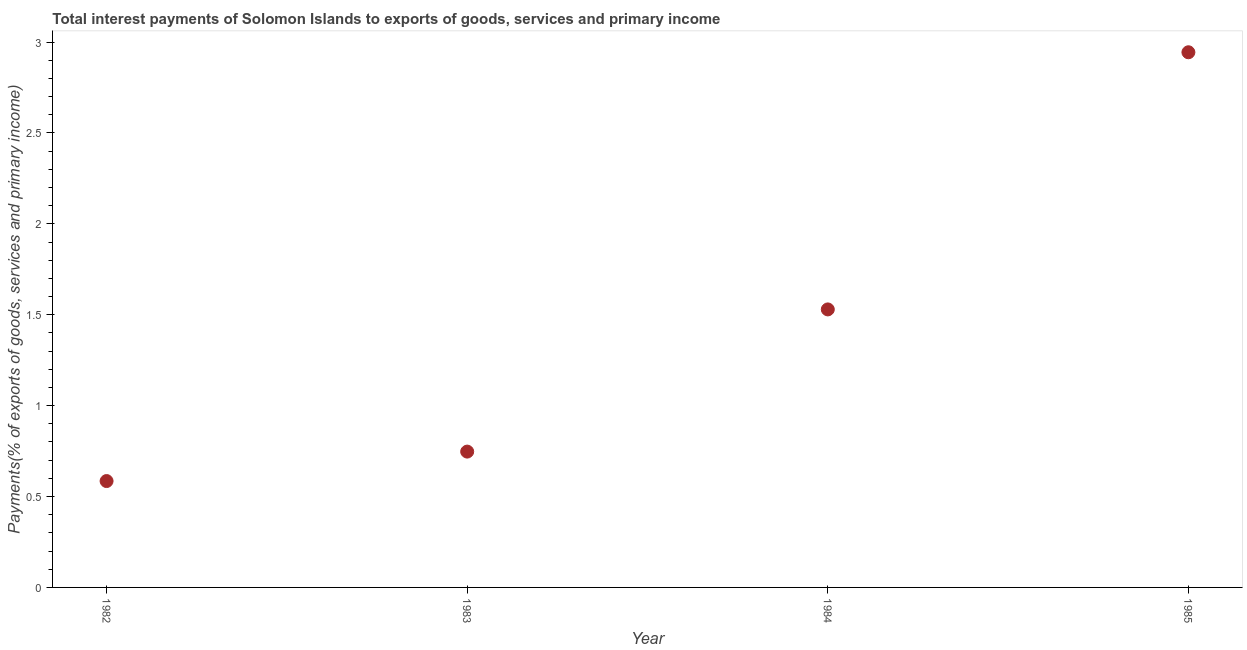What is the total interest payments on external debt in 1984?
Your response must be concise. 1.53. Across all years, what is the maximum total interest payments on external debt?
Offer a terse response. 2.94. Across all years, what is the minimum total interest payments on external debt?
Your answer should be compact. 0.59. In which year was the total interest payments on external debt minimum?
Provide a succinct answer. 1982. What is the sum of the total interest payments on external debt?
Provide a succinct answer. 5.81. What is the difference between the total interest payments on external debt in 1982 and 1984?
Keep it short and to the point. -0.94. What is the average total interest payments on external debt per year?
Provide a succinct answer. 1.45. What is the median total interest payments on external debt?
Provide a succinct answer. 1.14. What is the ratio of the total interest payments on external debt in 1982 to that in 1983?
Offer a terse response. 0.78. Is the total interest payments on external debt in 1982 less than that in 1983?
Offer a very short reply. Yes. What is the difference between the highest and the second highest total interest payments on external debt?
Your answer should be very brief. 1.41. What is the difference between the highest and the lowest total interest payments on external debt?
Keep it short and to the point. 2.36. In how many years, is the total interest payments on external debt greater than the average total interest payments on external debt taken over all years?
Your answer should be very brief. 2. Does the total interest payments on external debt monotonically increase over the years?
Ensure brevity in your answer.  Yes. What is the difference between two consecutive major ticks on the Y-axis?
Provide a short and direct response. 0.5. Does the graph contain grids?
Ensure brevity in your answer.  No. What is the title of the graph?
Offer a terse response. Total interest payments of Solomon Islands to exports of goods, services and primary income. What is the label or title of the Y-axis?
Keep it short and to the point. Payments(% of exports of goods, services and primary income). What is the Payments(% of exports of goods, services and primary income) in 1982?
Give a very brief answer. 0.59. What is the Payments(% of exports of goods, services and primary income) in 1983?
Make the answer very short. 0.75. What is the Payments(% of exports of goods, services and primary income) in 1984?
Offer a very short reply. 1.53. What is the Payments(% of exports of goods, services and primary income) in 1985?
Keep it short and to the point. 2.94. What is the difference between the Payments(% of exports of goods, services and primary income) in 1982 and 1983?
Keep it short and to the point. -0.16. What is the difference between the Payments(% of exports of goods, services and primary income) in 1982 and 1984?
Your answer should be very brief. -0.94. What is the difference between the Payments(% of exports of goods, services and primary income) in 1982 and 1985?
Provide a succinct answer. -2.36. What is the difference between the Payments(% of exports of goods, services and primary income) in 1983 and 1984?
Your answer should be compact. -0.78. What is the difference between the Payments(% of exports of goods, services and primary income) in 1983 and 1985?
Provide a succinct answer. -2.2. What is the difference between the Payments(% of exports of goods, services and primary income) in 1984 and 1985?
Your answer should be very brief. -1.41. What is the ratio of the Payments(% of exports of goods, services and primary income) in 1982 to that in 1983?
Offer a very short reply. 0.78. What is the ratio of the Payments(% of exports of goods, services and primary income) in 1982 to that in 1984?
Your response must be concise. 0.38. What is the ratio of the Payments(% of exports of goods, services and primary income) in 1982 to that in 1985?
Your response must be concise. 0.2. What is the ratio of the Payments(% of exports of goods, services and primary income) in 1983 to that in 1984?
Give a very brief answer. 0.49. What is the ratio of the Payments(% of exports of goods, services and primary income) in 1983 to that in 1985?
Make the answer very short. 0.25. What is the ratio of the Payments(% of exports of goods, services and primary income) in 1984 to that in 1985?
Your answer should be very brief. 0.52. 